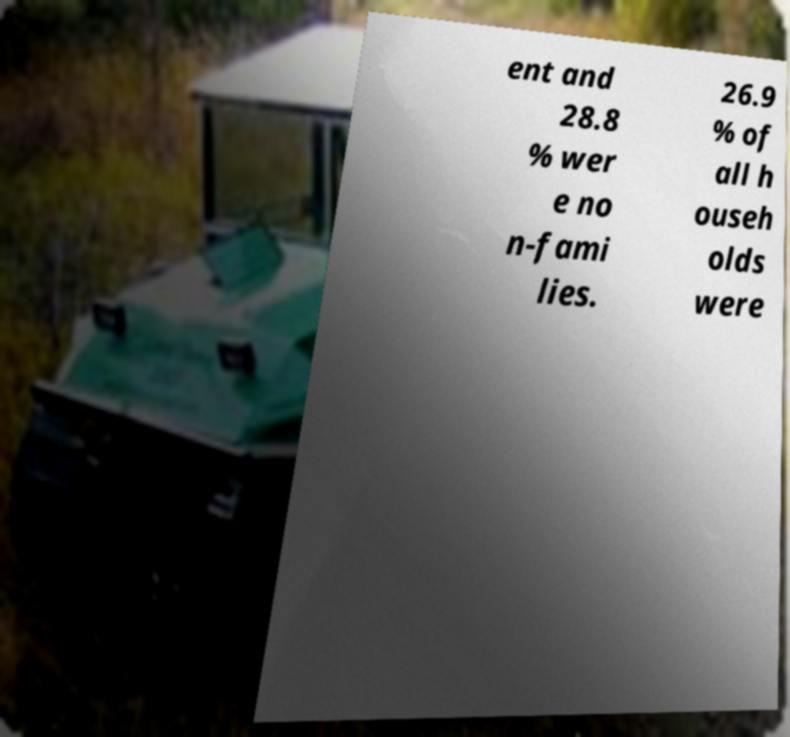Please read and relay the text visible in this image. What does it say? ent and 28.8 % wer e no n-fami lies. 26.9 % of all h ouseh olds were 